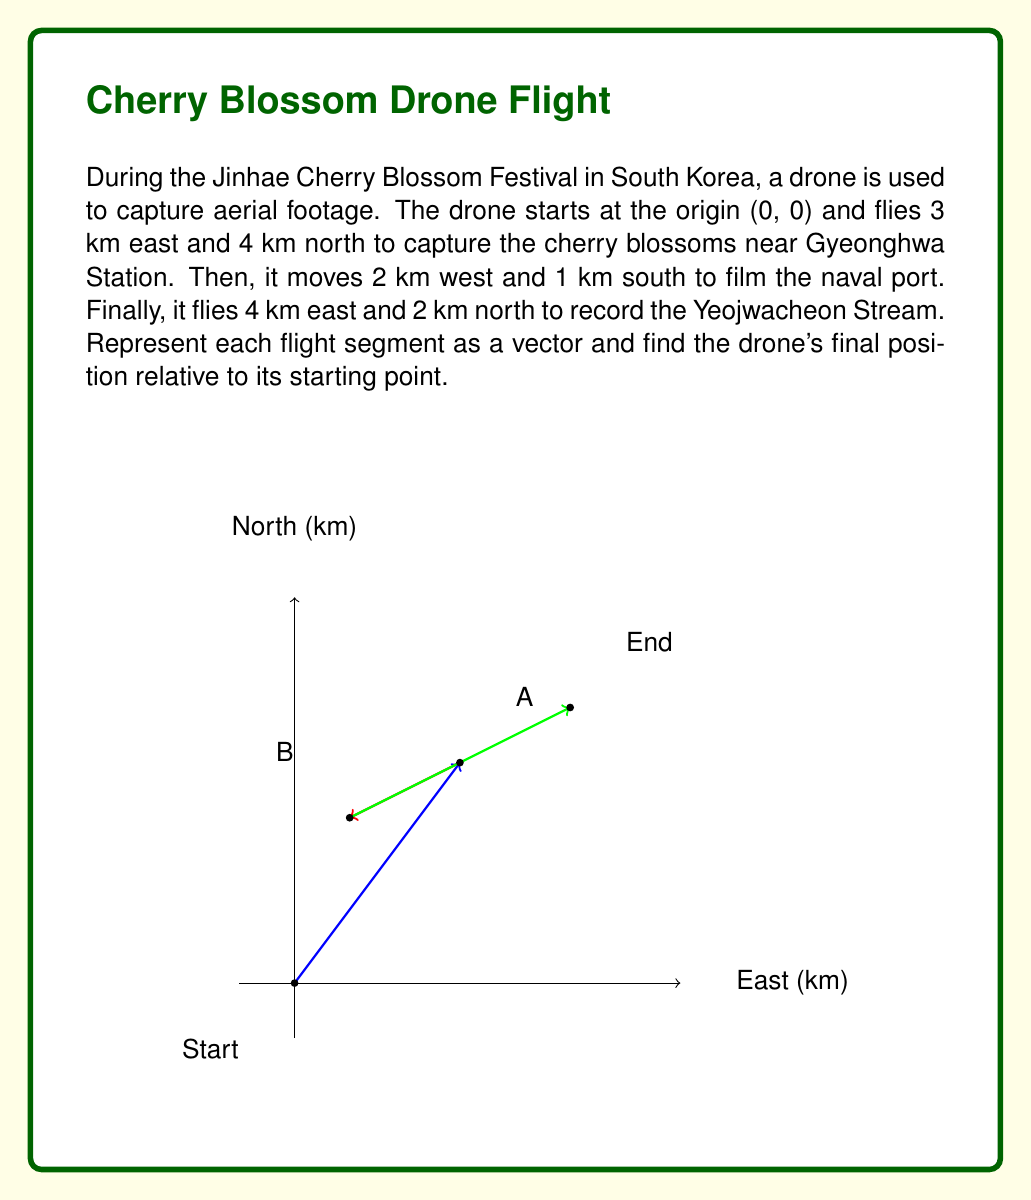Can you answer this question? Let's solve this problem step by step using vector addition:

1) First, let's represent each flight segment as a vector:
   - Segment 1: $\vec{v_1} = (3, 4)$
   - Segment 2: $\vec{v_2} = (-2, -1)$
   - Segment 3: $\vec{v_3} = (4, 2)$

2) To find the drone's final position, we need to add these vectors:
   $\vec{v_{final}} = \vec{v_1} + \vec{v_2} + \vec{v_3}$

3) Let's add the x-components and y-components separately:
   x-component: $3 + (-2) + 4 = 5$
   y-component: $4 + (-1) + 2 = 5$

4) Therefore, the final position vector is:
   $\vec{v_{final}} = (5, 5)$

5) This means the drone's final position is 5 km east and 5 km north of its starting point.

6) We can verify this by calculating the magnitude of the final vector:
   $\|\vec{v_{final}}\| = \sqrt{5^2 + 5^2} = \sqrt{50} = 5\sqrt{2} \approx 7.07$ km

This matches the direct distance from the origin to the point (5, 5) on our coordinate plane.
Answer: $(5, 5)$ 